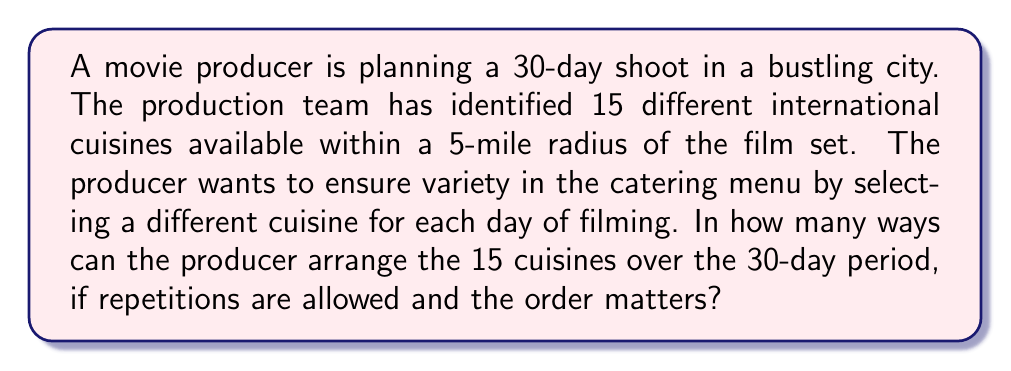Can you answer this question? Let's approach this step-by-step:

1) This is a problem of arrangements with repetition allowed. We are selecting a cuisine for each of the 30 days, and we can use the same cuisine on multiple days.

2) For each day, we have 15 choices of cuisine.

3) We are making this choice 30 times (once for each day of filming).

4) In such cases, we use the multiplication principle.

5) The formula for this type of problem is:

   $$ n^r $$

   Where $n$ is the number of options for each choice, and $r$ is the number of choices being made.

6) In this case, $n = 15$ (cuisines) and $r = 30$ (days).

7) Therefore, the number of possible arrangements is:

   $$ 15^{30} $$

8) This is a very large number. We can calculate it:

   $$ 15^{30} = 9.31322575 \times 10^{34} $$
Answer: $15^{30} = 9.31322575 \times 10^{34}$ 